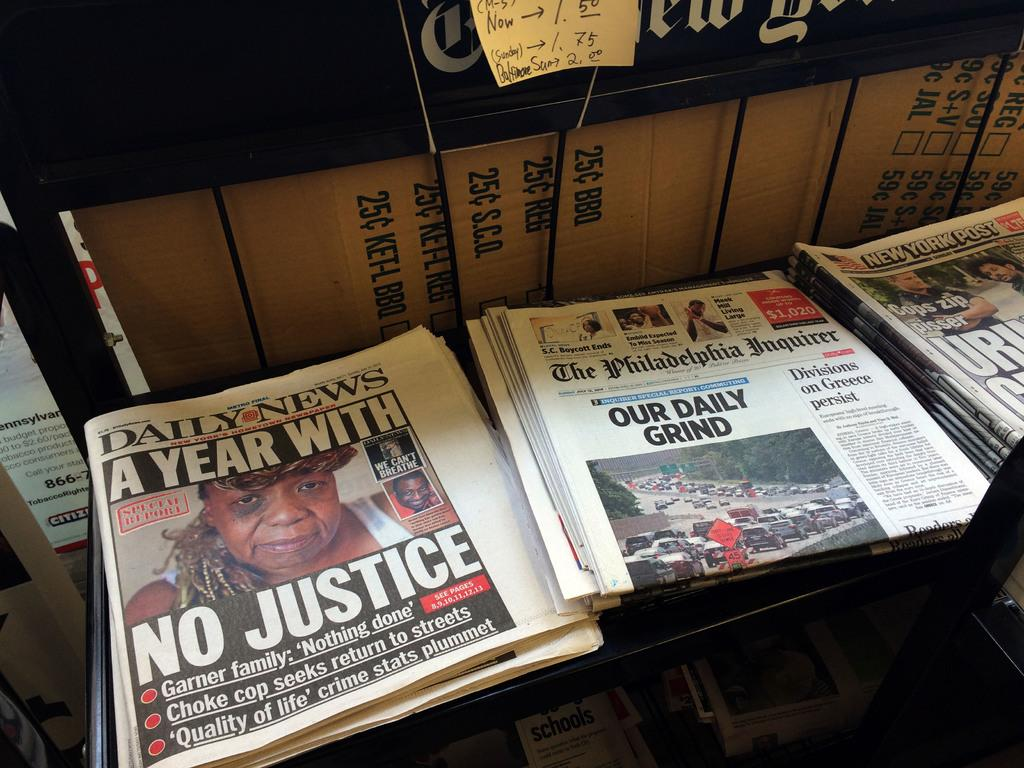<image>
Summarize the visual content of the image. Our Daily Grind newspaper in between some other newspapers. 